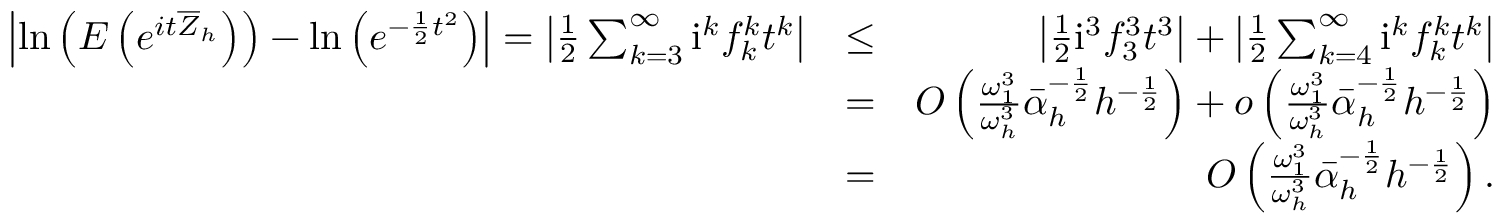Convert formula to latex. <formula><loc_0><loc_0><loc_500><loc_500>\begin{array} { r l r } { \left | \ln \left ( E \left ( e ^ { i t \overline { Z } _ { h } } \right ) \right ) - \ln \left ( e ^ { - \frac { 1 } { 2 } t ^ { 2 } } \right ) \right | = \left | \frac { 1 } { 2 } \sum _ { k = 3 } ^ { \infty } i ^ { k } f _ { k } ^ { k } t ^ { k } \right | } & { \leq } & { \left | \frac { 1 } { 2 } i ^ { 3 } f _ { 3 } ^ { 3 } t ^ { 3 } \right | + \left | \frac { 1 } { 2 } \sum _ { k = 4 } ^ { \infty } i ^ { k } f _ { k } ^ { k } t ^ { k } \right | } \\ & { = } & { O \left ( \frac { \omega _ { 1 } ^ { 3 } } { \omega _ { h } ^ { 3 } } \bar { \alpha } _ { h } ^ { - \frac { 1 } { 2 } } h ^ { - \frac { 1 } { 2 } } \right ) + o \left ( \frac { \omega _ { 1 } ^ { 3 } } { \omega _ { h } ^ { 3 } } \bar { \alpha } _ { h } ^ { - \frac { 1 } { 2 } } h ^ { - \frac { 1 } { 2 } } \right ) } \\ & { = } & { O \left ( \frac { \omega _ { 1 } ^ { 3 } } { \omega _ { h } ^ { 3 } } \bar { \alpha } _ { h } ^ { - \frac { 1 } { 2 } } h ^ { - \frac { 1 } { 2 } } \right ) . } \end{array}</formula> 